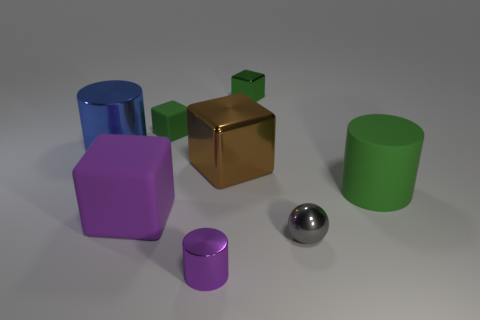How many green cylinders are the same size as the blue object?
Your answer should be very brief. 1. There is a metallic thing that is to the left of the purple cylinder; what number of blue shiny things are on the right side of it?
Your answer should be very brief. 0. Do the green block that is left of the large brown metallic object and the small gray ball have the same material?
Keep it short and to the point. No. Does the cylinder that is in front of the small shiny sphere have the same material as the large cylinder that is in front of the big metal cylinder?
Keep it short and to the point. No. Are there more big brown cubes in front of the gray object than shiny cubes?
Your answer should be compact. No. What is the color of the shiny ball right of the cube in front of the large rubber cylinder?
Ensure brevity in your answer.  Gray. There is a blue thing that is the same size as the green cylinder; what is its shape?
Provide a short and direct response. Cylinder. Are there the same number of tiny metal cubes and big purple shiny objects?
Offer a terse response. No. What is the shape of the rubber object that is the same color as the big matte cylinder?
Make the answer very short. Cube. Are there an equal number of large matte objects that are to the left of the purple block and purple shiny things?
Provide a succinct answer. No. 